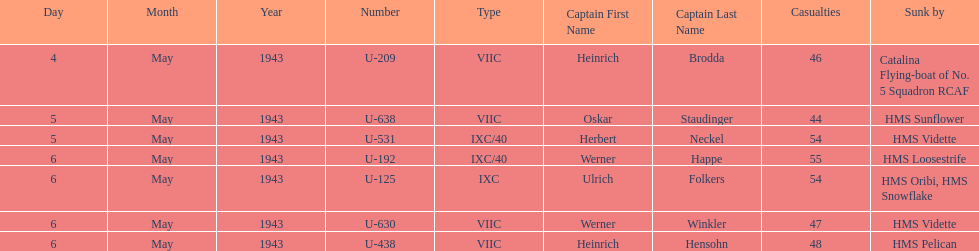Which u-boat had more than 54 casualties? U-192. 